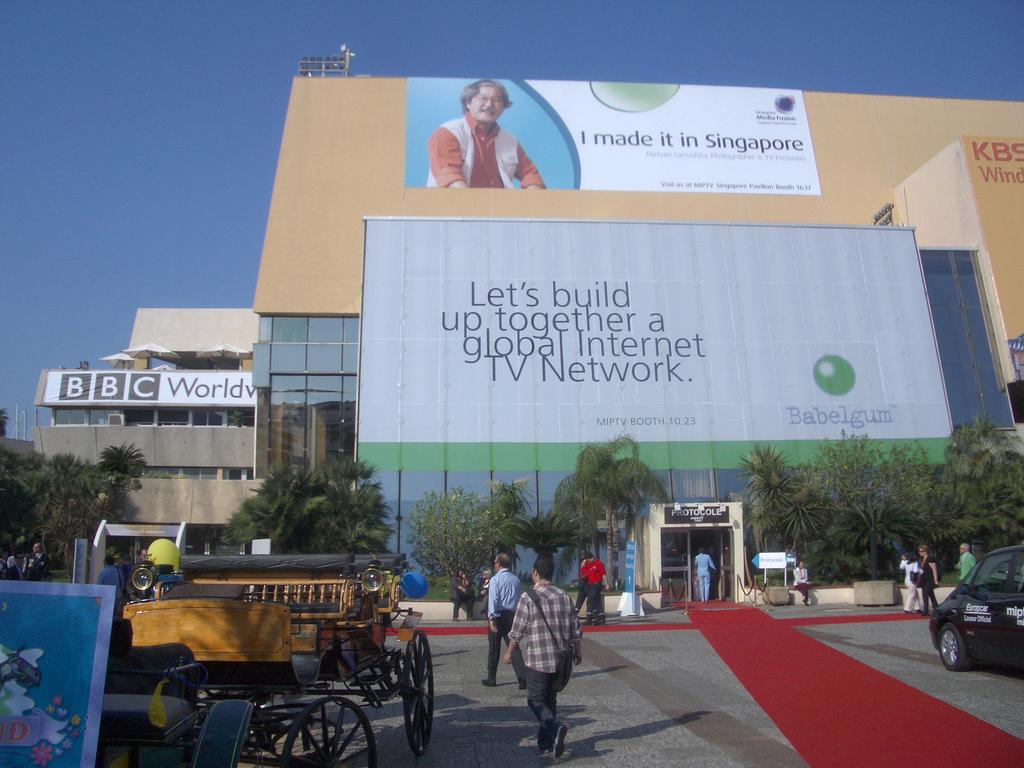<image>
Give a short and clear explanation of the subsequent image. People walking outside of a building with a large Babelgum billboard on it. 